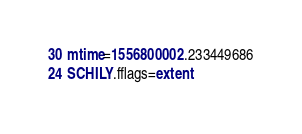Convert code to text. <code><loc_0><loc_0><loc_500><loc_500><_CSS_>30 mtime=1556800002.233449686
24 SCHILY.fflags=extent
</code> 